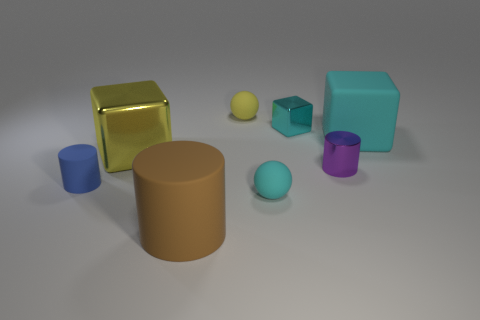Are there more cubes in front of the brown matte object than brown rubber things?
Give a very brief answer. No. Is there a small cylinder of the same color as the small cube?
Keep it short and to the point. No. What is the color of the other cube that is the same size as the yellow metallic cube?
Ensure brevity in your answer.  Cyan. Is the number of tiny things the same as the number of small red shiny spheres?
Give a very brief answer. No. How many small yellow rubber spheres are to the left of the big block that is left of the big cyan rubber cube?
Provide a short and direct response. 0. What number of things are metallic things that are on the left side of the large brown rubber thing or tiny yellow matte spheres?
Offer a very short reply. 2. How many tiny balls are the same material as the large yellow thing?
Offer a terse response. 0. There is a matte thing that is the same color as the large rubber cube; what is its shape?
Offer a terse response. Sphere. Is the number of balls that are behind the small metal block the same as the number of big matte cylinders?
Your response must be concise. Yes. There is a brown matte object that is in front of the small cube; what size is it?
Your answer should be very brief. Large. 